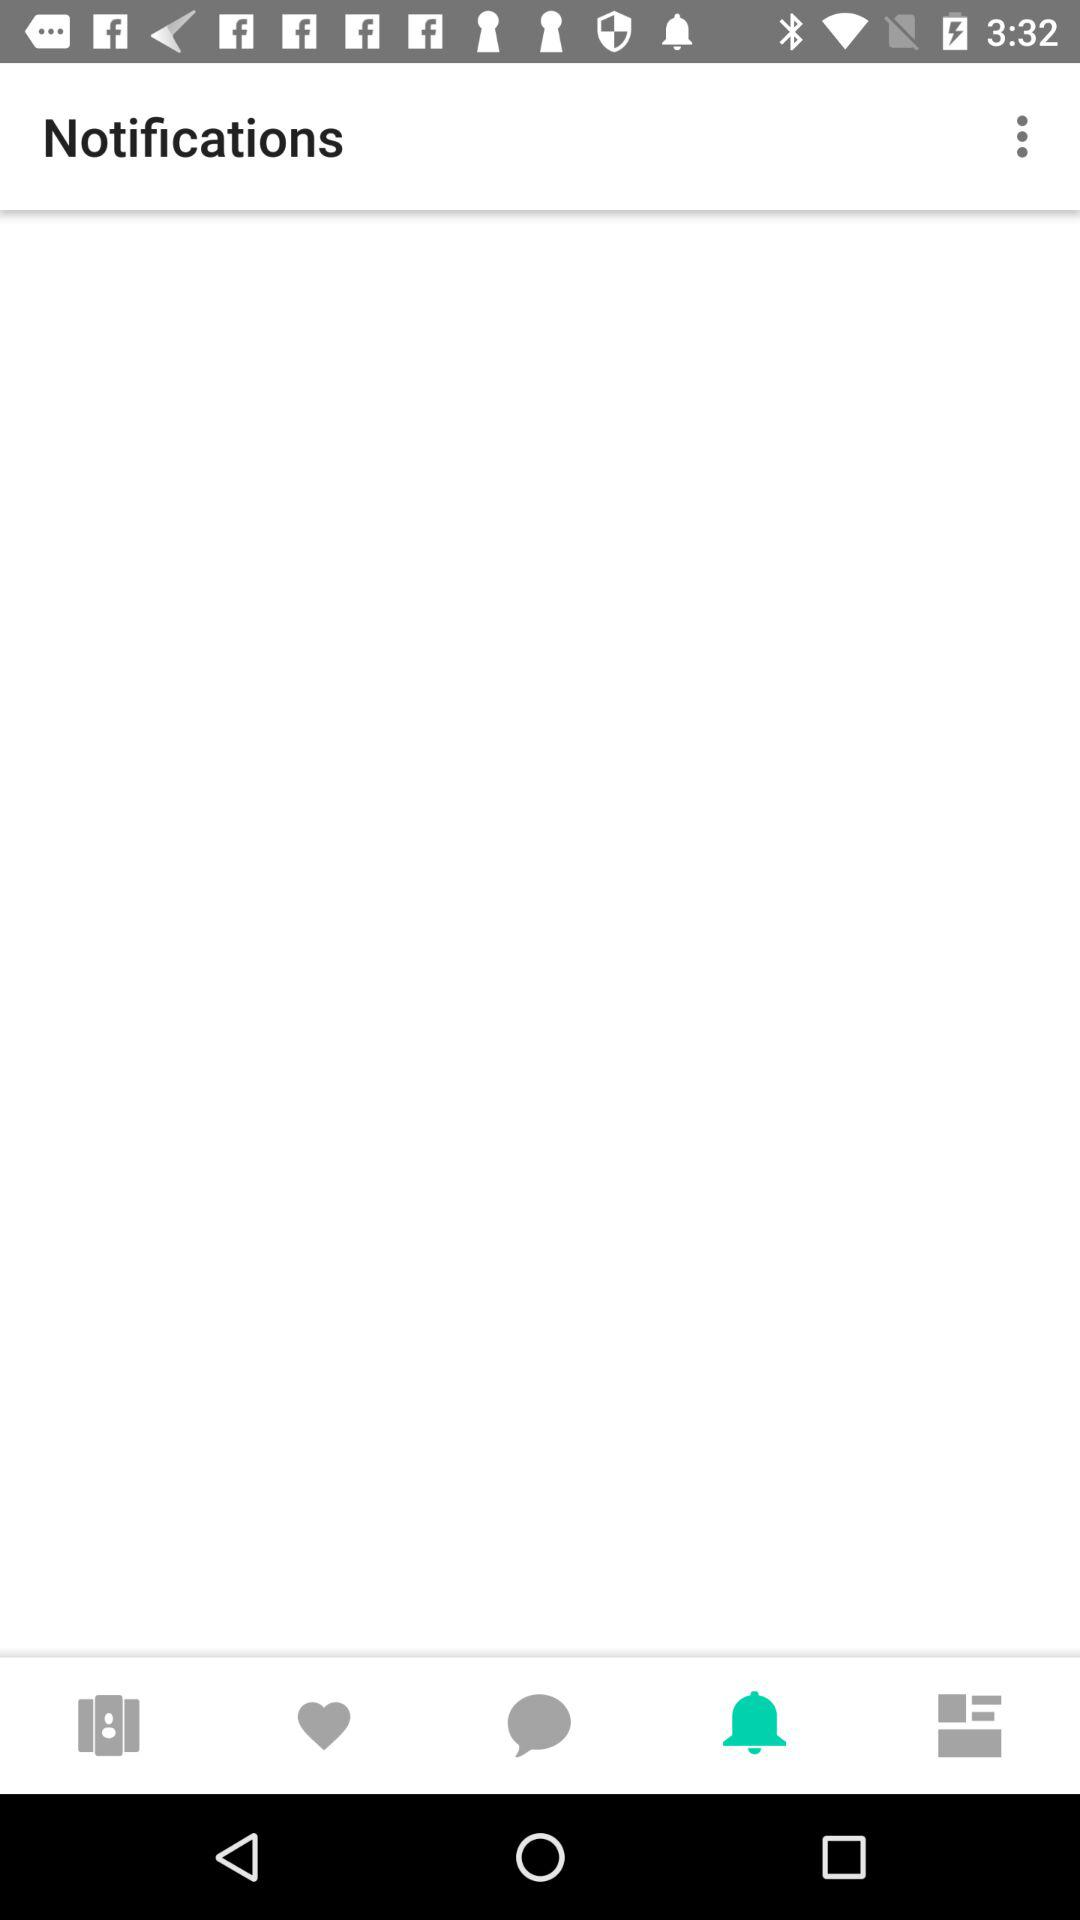Which tab is selected? The selected tab is "Notifications". 